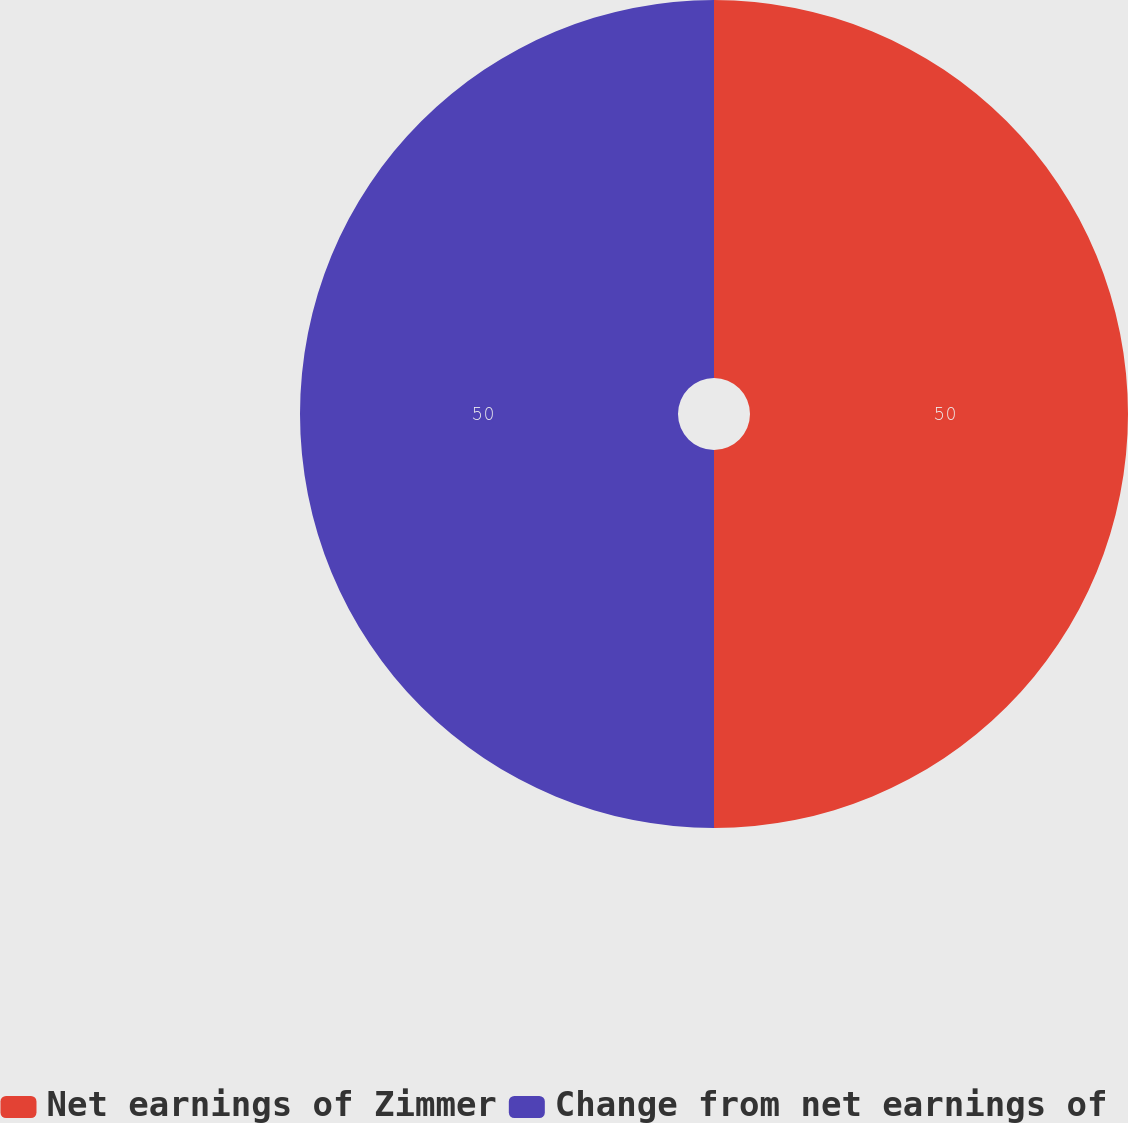<chart> <loc_0><loc_0><loc_500><loc_500><pie_chart><fcel>Net earnings of Zimmer<fcel>Change from net earnings of<nl><fcel>50.0%<fcel>50.0%<nl></chart> 